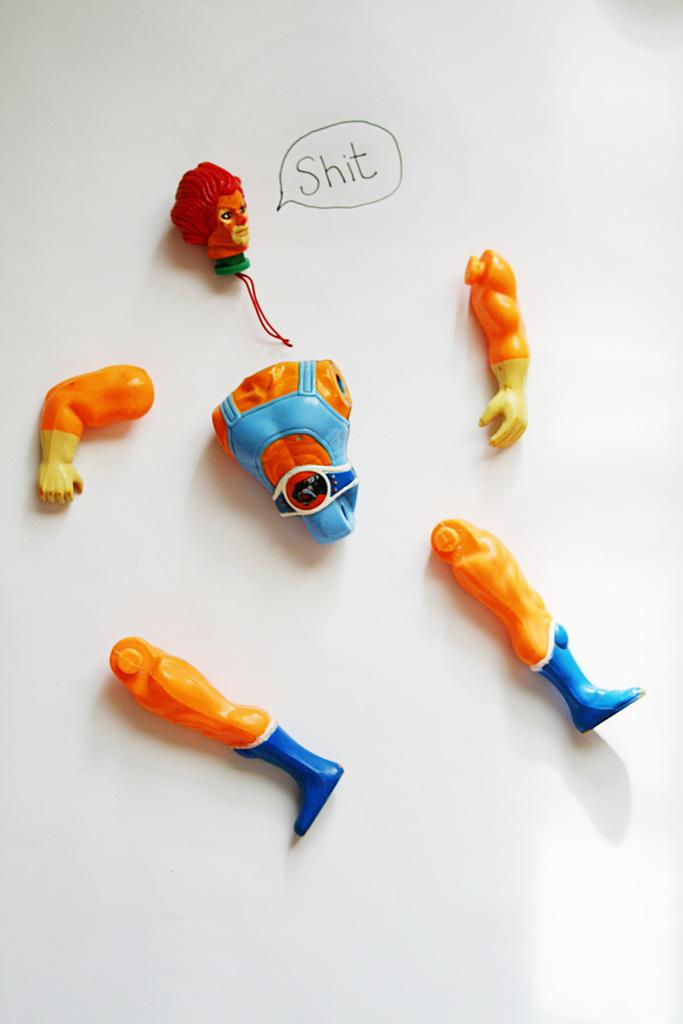What can be seen in the image that is related to a toy? There are parts of a toy in the image. What else is present in the image besides the toy parts? There is text on a white surface in the image. How many cherries are on the wool in the image? There is no wool or cherries present in the image. 